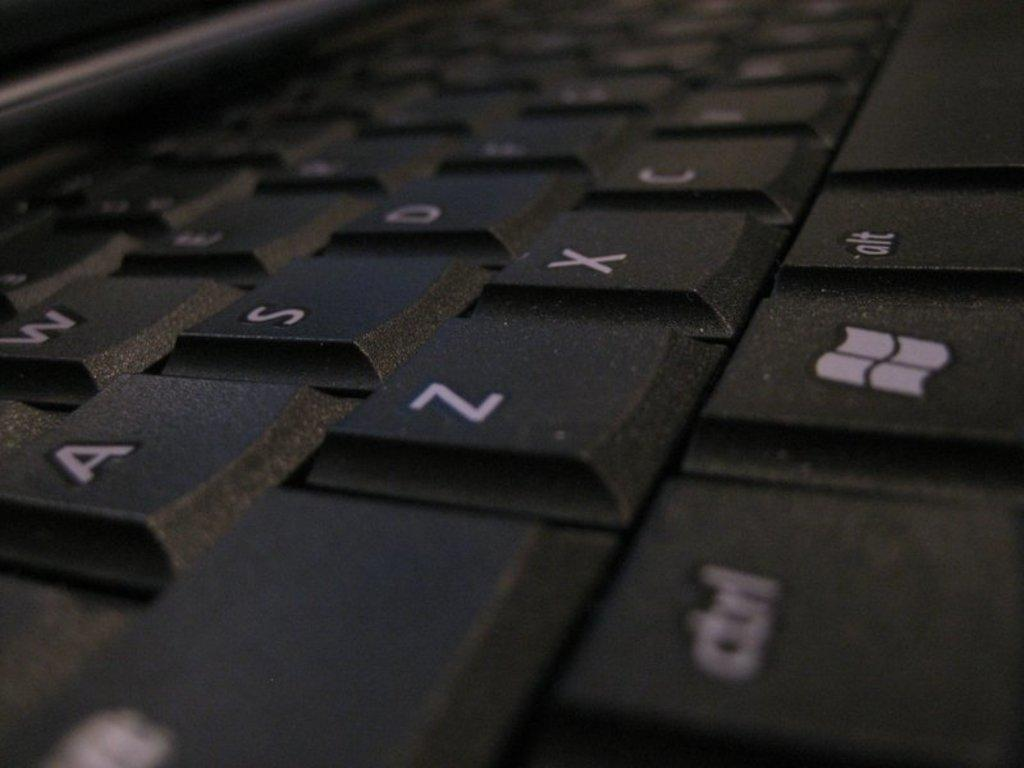<image>
Share a concise interpretation of the image provided. A close up of a keyboard with the control key on the bottom left. 